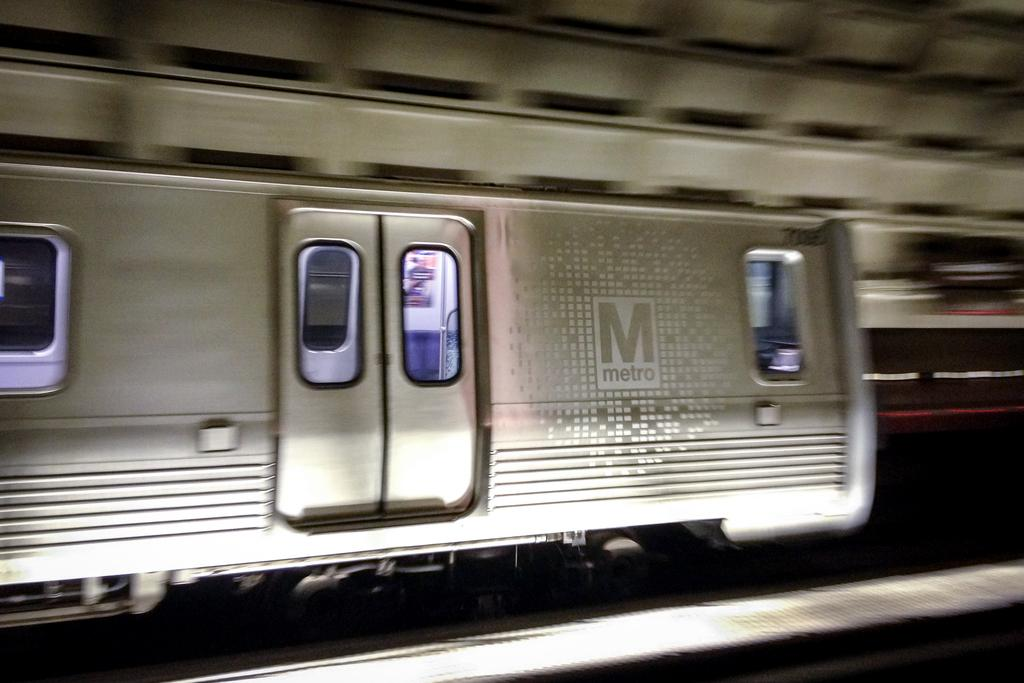<image>
Describe the image concisely. A Metro subway train is leaving the underground station. 